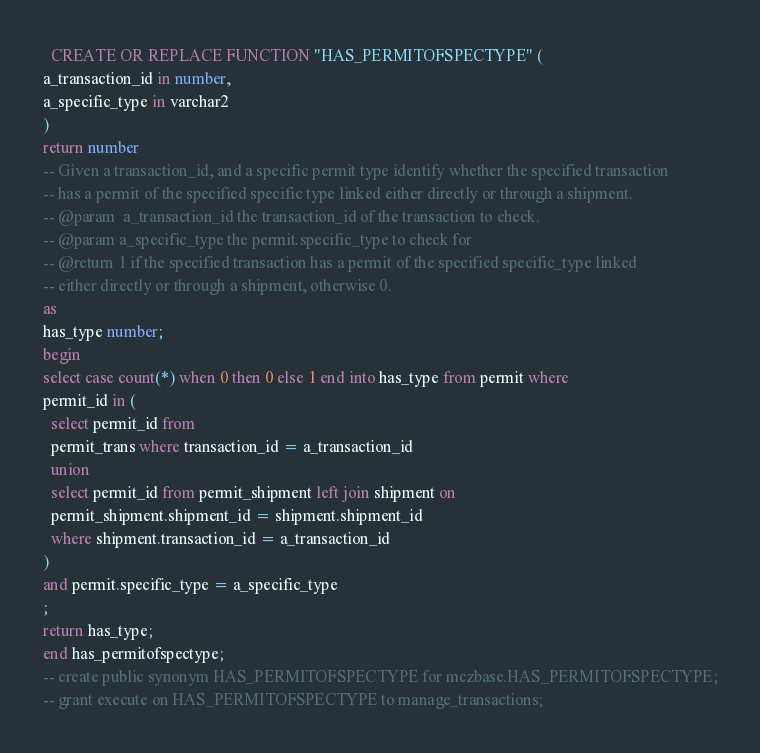<code> <loc_0><loc_0><loc_500><loc_500><_SQL_>
  CREATE OR REPLACE FUNCTION "HAS_PERMITOFSPECTYPE" (
a_transaction_id in number,
a_specific_type in varchar2
)
return number
-- Given a transaction_id, and a specific permit type identify whether the specified transaction
-- has a permit of the specified specific type linked either directly or through a shipment.
-- @param  a_transaction_id the transaction_id of the transaction to check.
-- @param a_specific_type the permit.specific_type to check for
-- @return 1 if the specified transaction has a permit of the specified specific_type linked 
-- either directly or through a shipment, otherwise 0.
as
has_type number;
begin
select case count(*) when 0 then 0 else 1 end into has_type from permit where
permit_id in (
  select permit_id from
  permit_trans where transaction_id = a_transaction_id
  union
  select permit_id from permit_shipment left join shipment on
  permit_shipment.shipment_id = shipment.shipment_id
  where shipment.transaction_id = a_transaction_id
)
and permit.specific_type = a_specific_type
;
return has_type;
end has_permitofspectype;
-- create public synonym HAS_PERMITOFSPECTYPE for mczbase.HAS_PERMITOFSPECTYPE;
-- grant execute on HAS_PERMITOFSPECTYPE to manage_transactions;</code> 